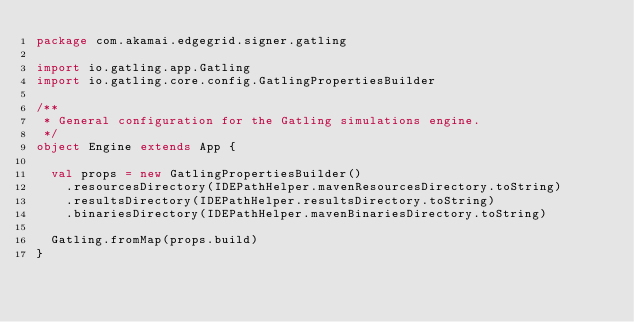Convert code to text. <code><loc_0><loc_0><loc_500><loc_500><_Scala_>package com.akamai.edgegrid.signer.gatling

import io.gatling.app.Gatling
import io.gatling.core.config.GatlingPropertiesBuilder

/**
 * General configuration for the Gatling simulations engine.
 */
object Engine extends App {

  val props = new GatlingPropertiesBuilder()
    .resourcesDirectory(IDEPathHelper.mavenResourcesDirectory.toString)
    .resultsDirectory(IDEPathHelper.resultsDirectory.toString)
    .binariesDirectory(IDEPathHelper.mavenBinariesDirectory.toString)

  Gatling.fromMap(props.build)
}
</code> 